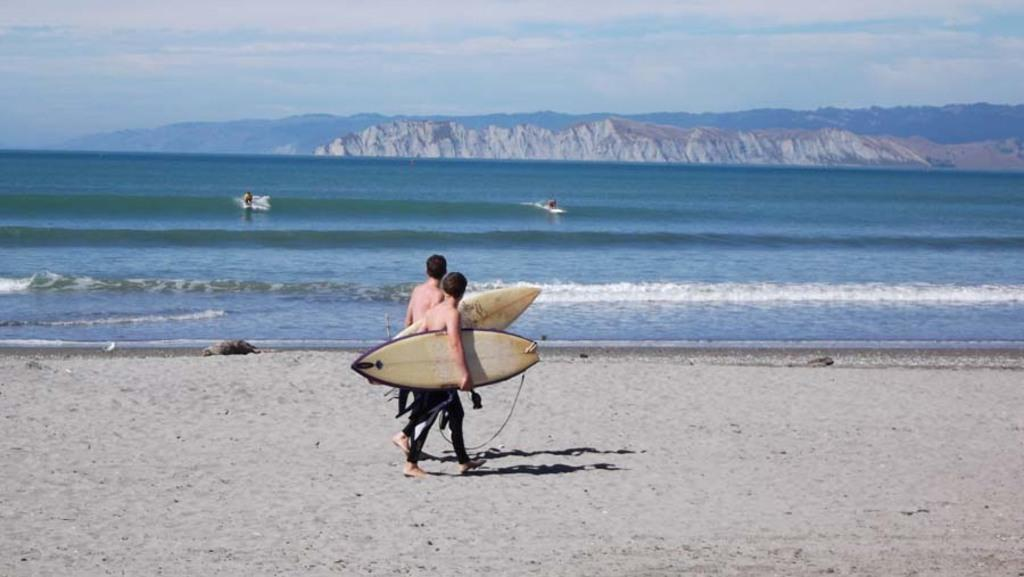How many people are in the image? There are two men in the image. What are the men doing in the image? The men are walking in the image. What are the men holding in their hands? The men are holding surfboards in their hands. What type of terrain are the men walking on? The men are walking on sand. What can be seen in the background of the image? Water, mountains, and the sky are visible in the background of the image. What is the condition of the sky in the image? Clouds are present in the sky. Where is the shop located in the image? There is no shop present in the image. What type of letters are the men writing on the surfboards in the image? The men are not writing any letters on the surfboards in the image. What type of amusement can be seen in the image? There is no amusement park or any amusement-related objects present in the image. 